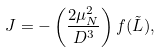<formula> <loc_0><loc_0><loc_500><loc_500>J = - \left ( \frac { 2 \mu _ { N } ^ { 2 } } { D ^ { 3 } } \right ) f ( \tilde { L } ) ,</formula> 